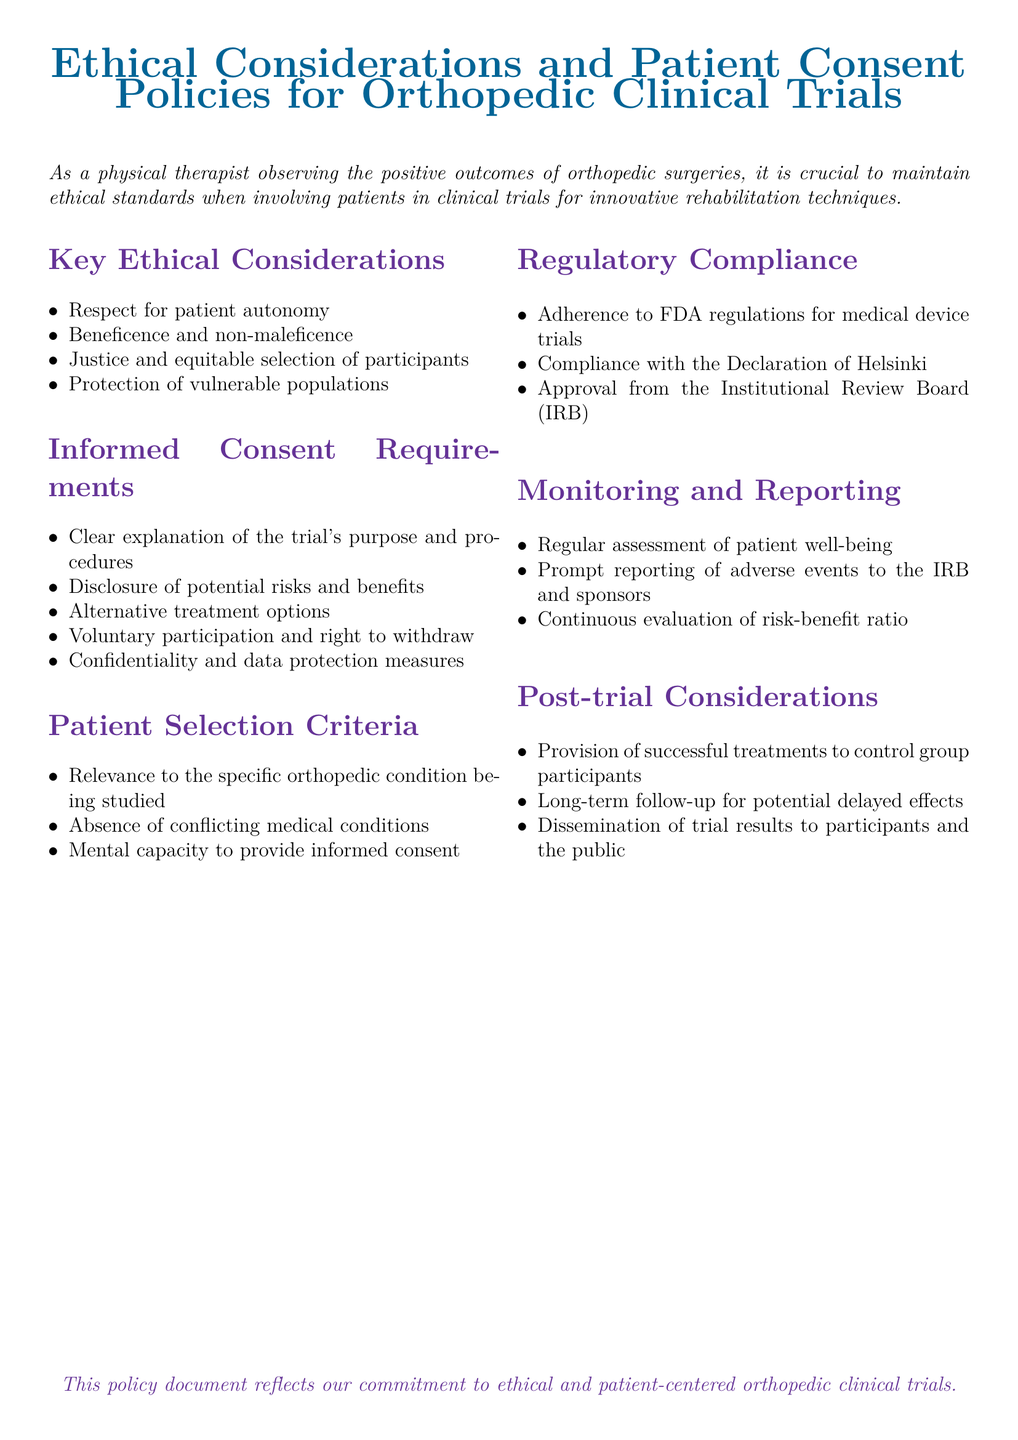What is the main focus of the document? The main focus of the document is the ethical considerations and patient consent policies for orthopedic clinical trials.
Answer: Ethical considerations and patient consent policies for orthopedic clinical trials What is one key ethical consideration mentioned? The document lists several key ethical considerations for clinical trials; one example is respect for patient autonomy.
Answer: Respect for patient autonomy What must be included in the informed consent process? Informed consent requires clear explanations of trial purposes and procedures, along with other information. One component is the disclosure of potential risks and benefits.
Answer: Disclosure of potential risks and benefits What regulatory body must approve the clinical trials? The document specifies that approval must come from the Institutional Review Board (IRB).
Answer: Institutional Review Board (IRB) What should be done if adverse events occur during the trial? The document states that adverse events must be promptly reported to the IRB and sponsors.
Answer: Prompt reporting to the IRB and sponsors What is a requirement for patient selection? A requirement stated in the document is that patients must be relevant to the specific orthopedic condition being studied.
Answer: Relevance to the specific orthopedic condition being studied What is a post-trial consideration mentioned? One of the post-trial considerations is the provision of successful treatments to control group participants.
Answer: Provision of successful treatments to control group participants How does the document suggest to handle confidentiality? The confidentiality aspect is included under informed consent requirements, stating that data protection measures must be taken.
Answer: Confidentiality and data protection measures What ethical principle ensures fair patient selection? The ethical principle that ensures fair selection of participants in the trials is justice.
Answer: Justice and equitable selection of participants 